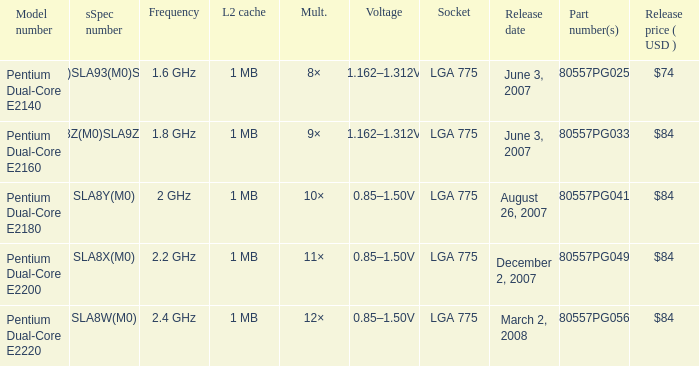What part number(s) has a frequency of 2.4 ghz? HH80557PG0561M. 